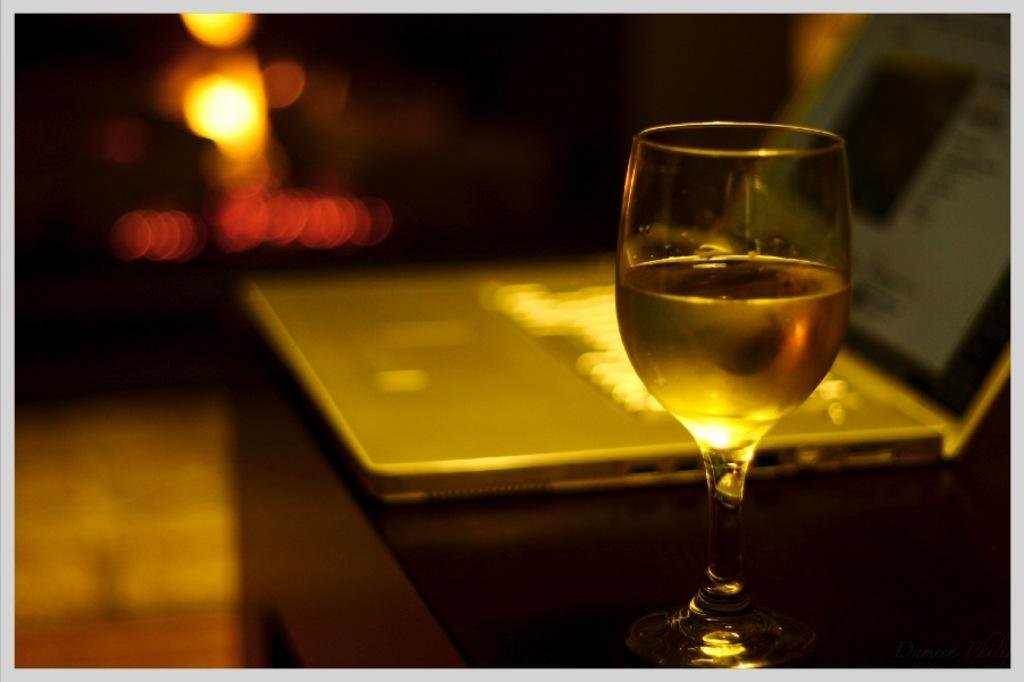What is in the glass that is visible in the image? There is a glass of wine in the image. What can be seen in the background of the image? There is a laptop on a desk in the background. What is visible at the bottom of the image? The floor is visible at the bottom of the image. How would you describe the background of the image? The background is blurred. What type of nerve is being studied on the laptop in the image? There is no indication of a nerve or any scientific study in the image; it features a glass of wine and a laptop on a desk in the background. 